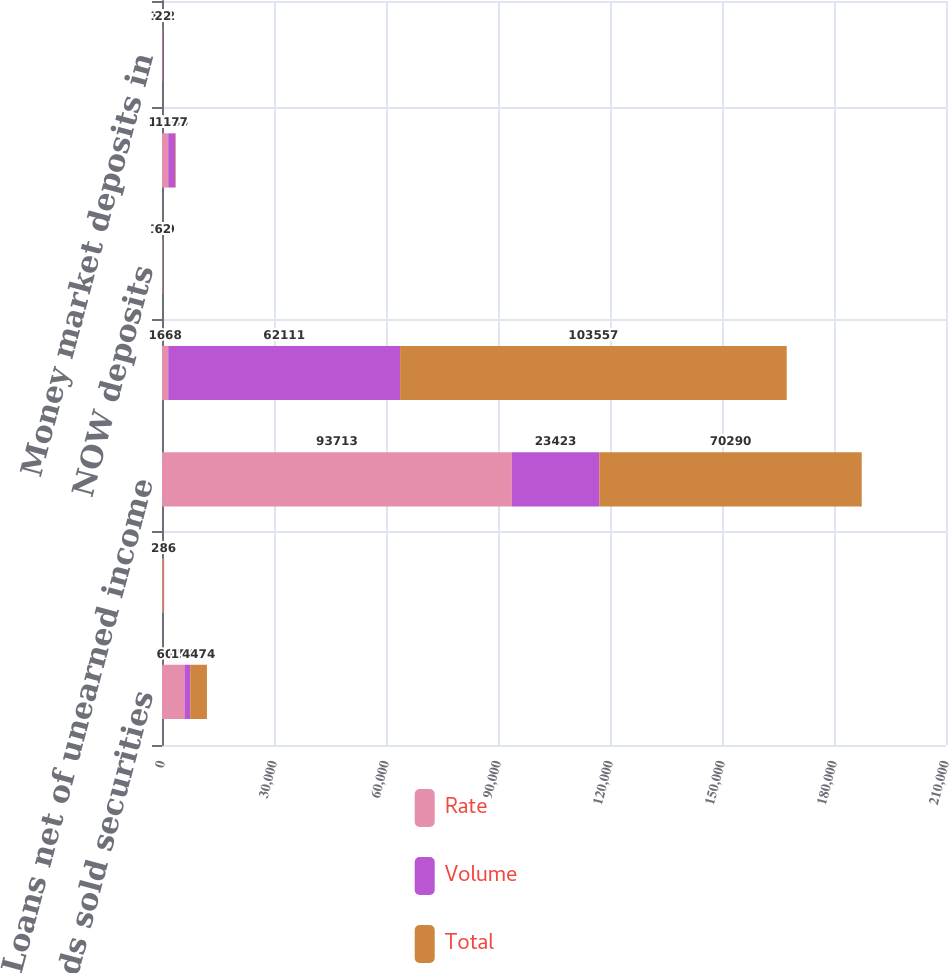Convert chart to OTSL. <chart><loc_0><loc_0><loc_500><loc_500><stacked_bar_chart><ecel><fcel>Federal funds sold securities<fcel>Available-for-sale securities<fcel>Loans net of unearned income<fcel>Increase (decrease) in<fcel>NOW deposits<fcel>Money market deposits<fcel>Money market deposits in<nl><fcel>Rate<fcel>6017<fcel>224<fcel>93713<fcel>1668<fcel>119<fcel>1668<fcel>124<nl><fcel>Volume<fcel>1543<fcel>62<fcel>23423<fcel>62111<fcel>57<fcel>1845<fcel>102<nl><fcel>Total<fcel>4474<fcel>286<fcel>70290<fcel>103557<fcel>62<fcel>177<fcel>22<nl></chart> 